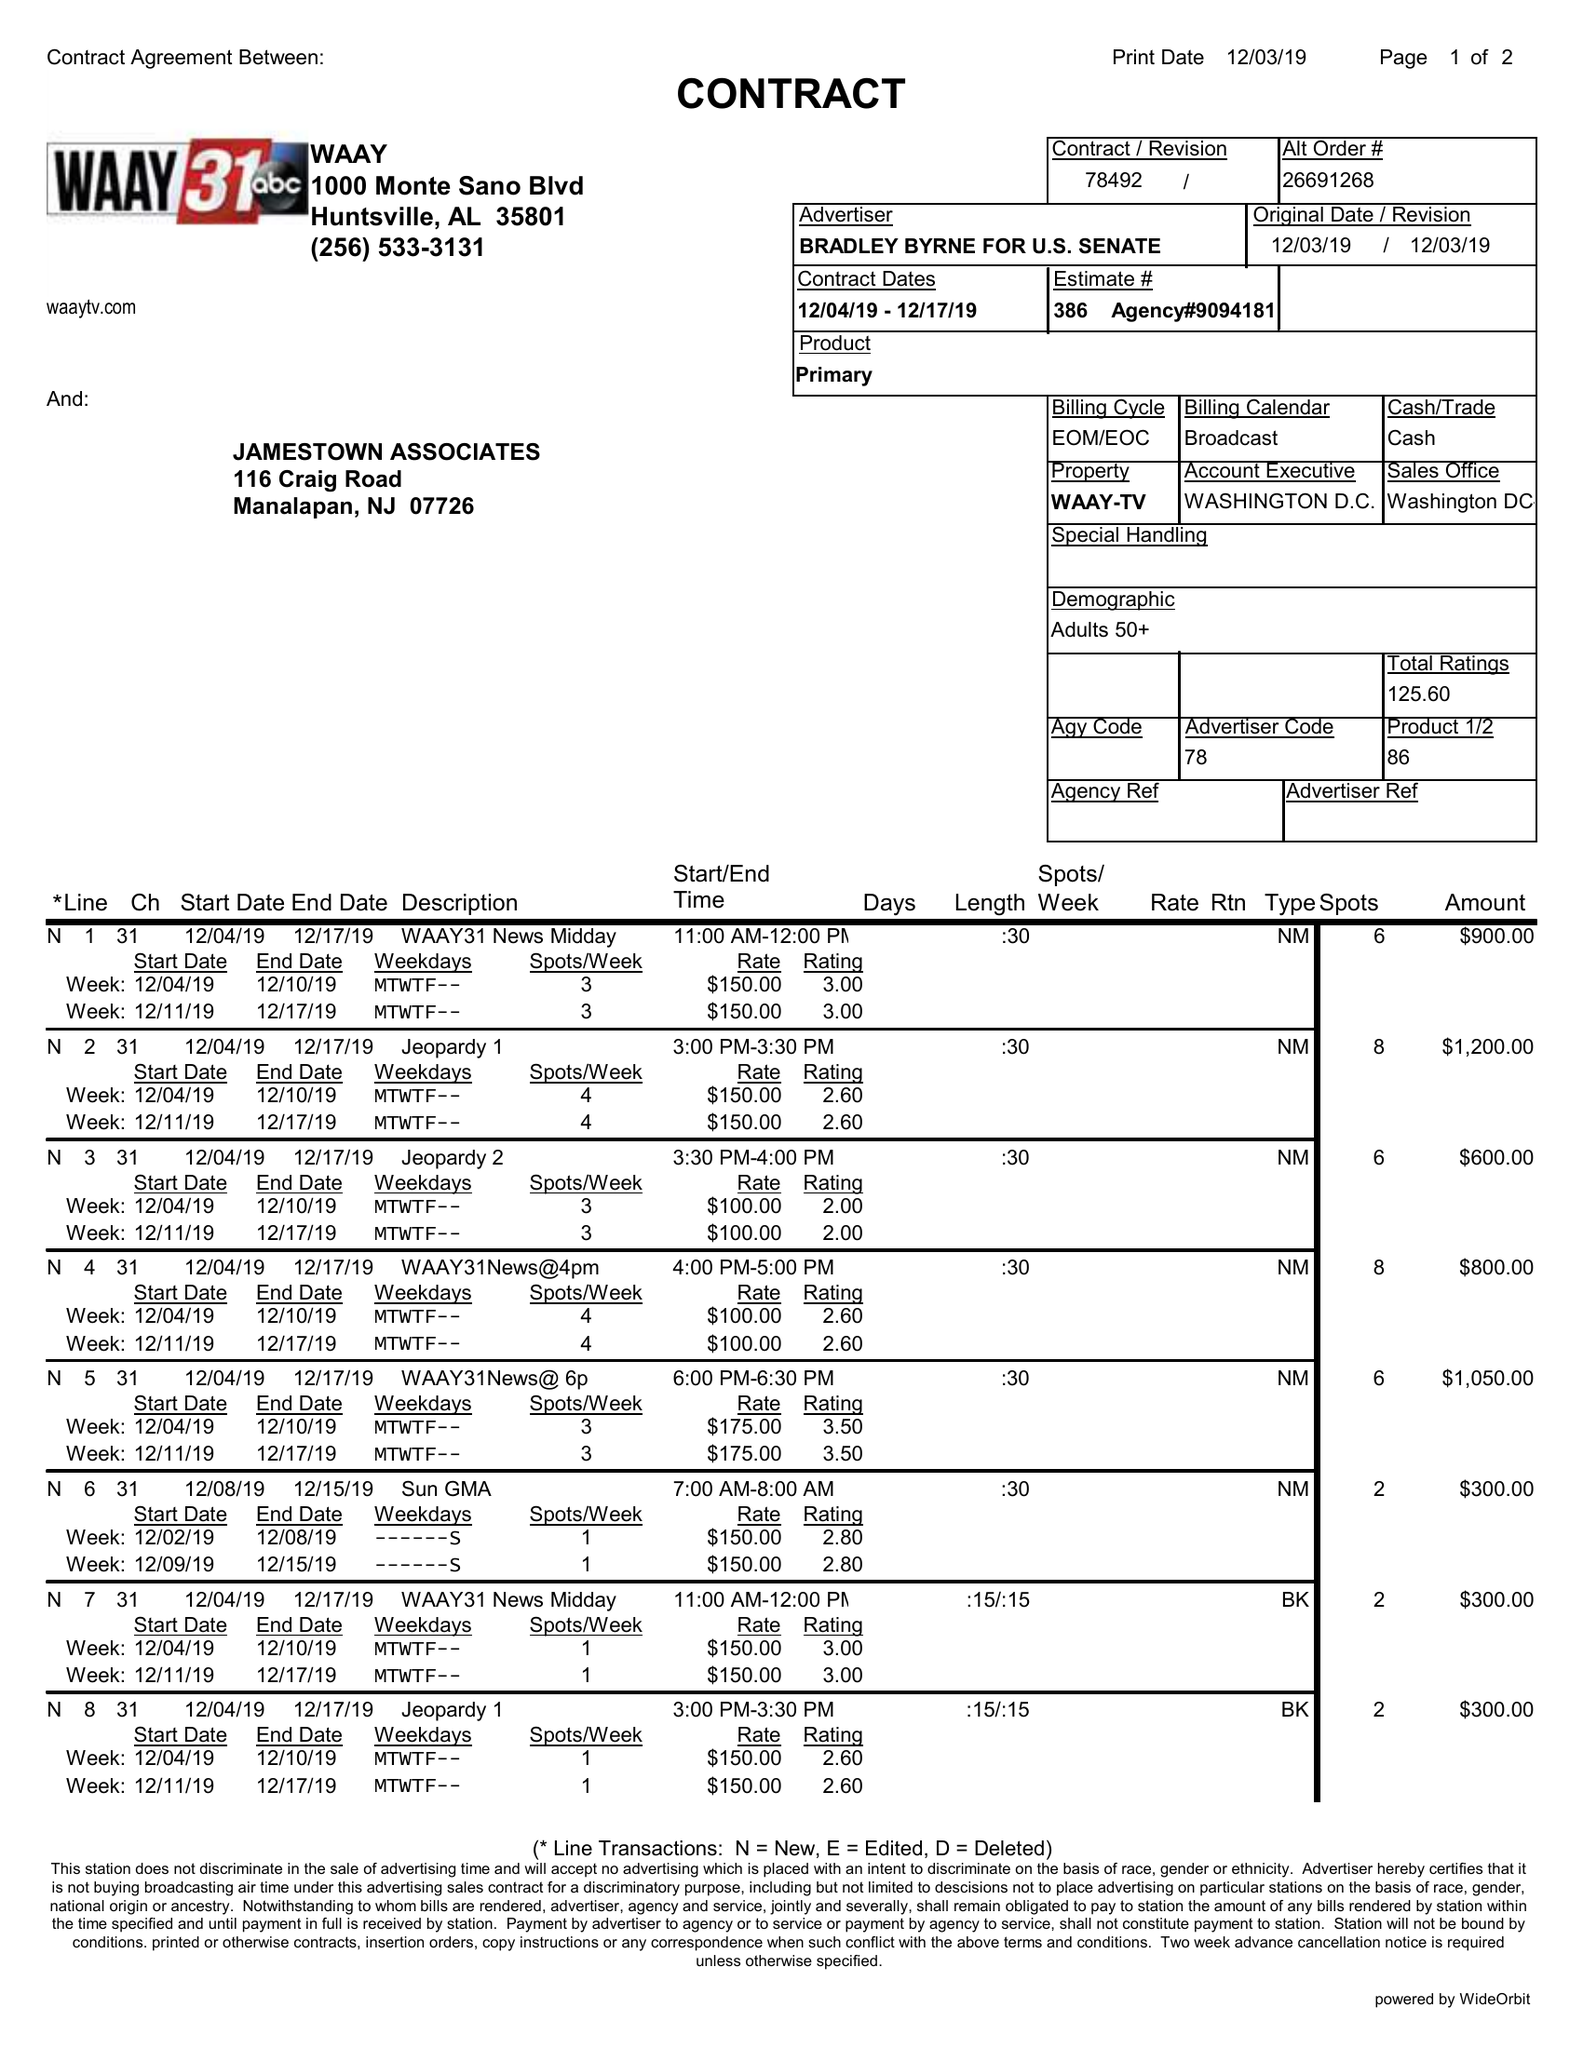What is the value for the flight_from?
Answer the question using a single word or phrase. 12/04/19 